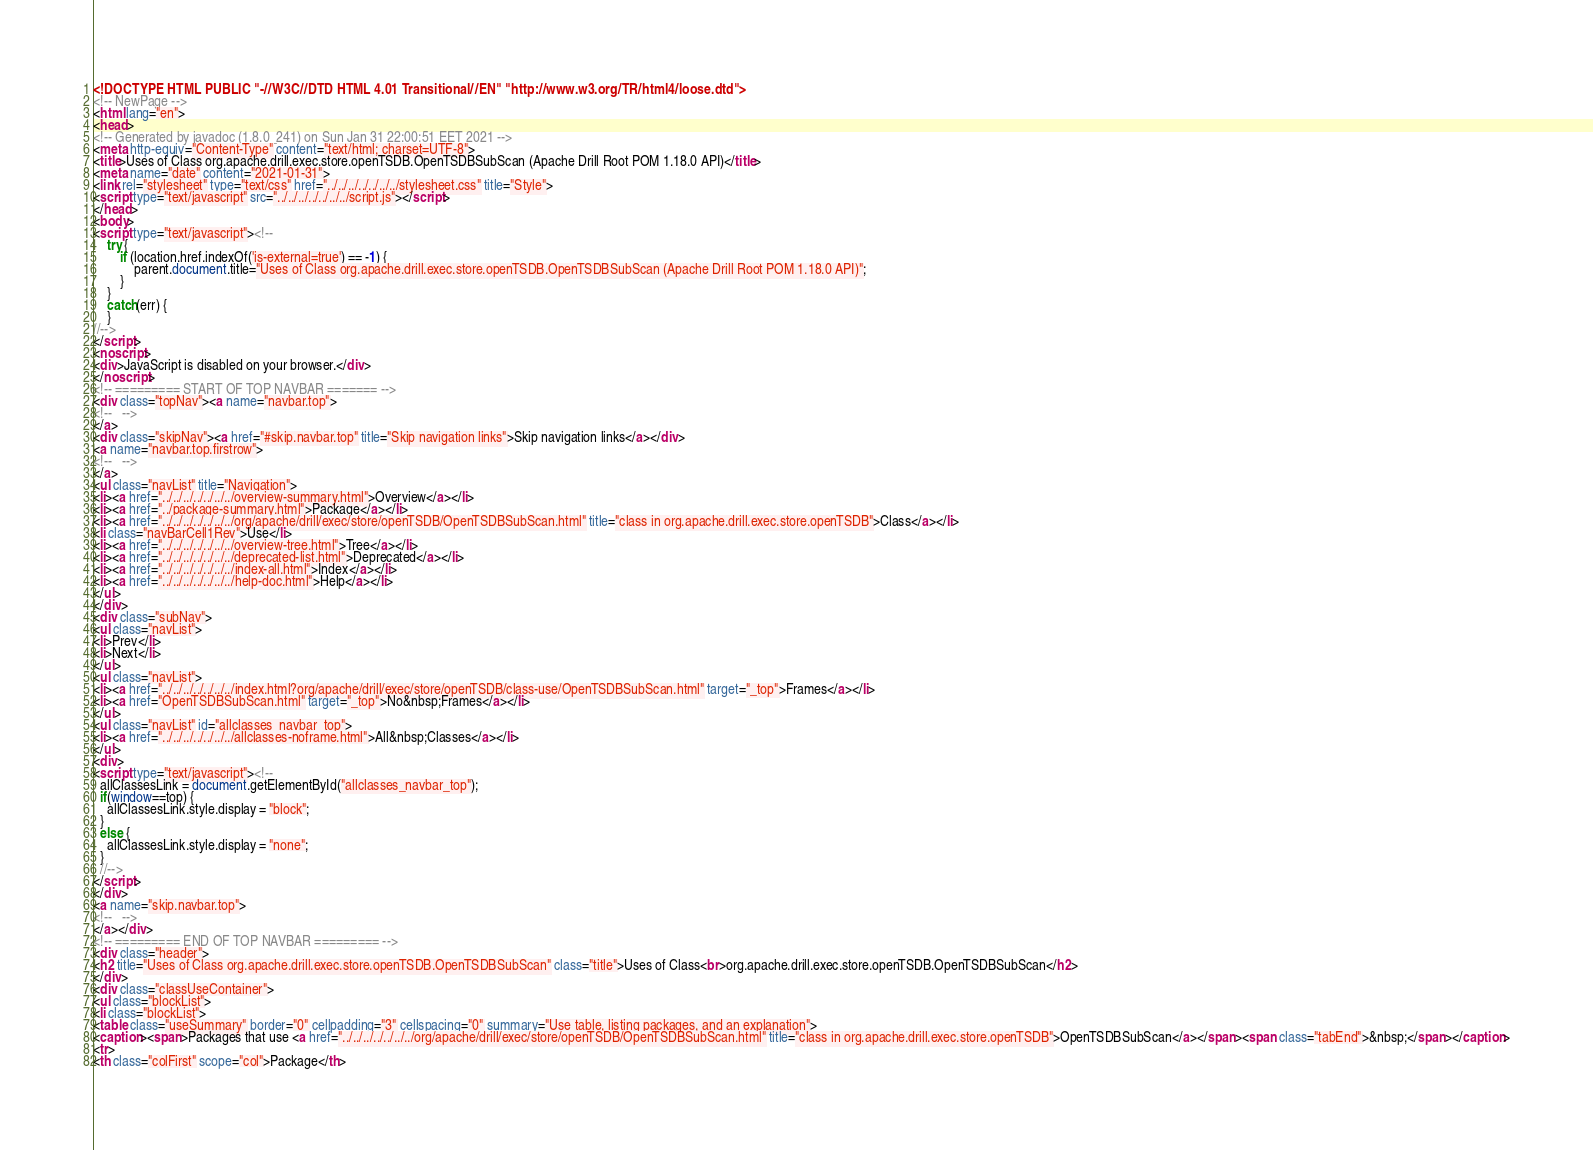Convert code to text. <code><loc_0><loc_0><loc_500><loc_500><_HTML_><!DOCTYPE HTML PUBLIC "-//W3C//DTD HTML 4.01 Transitional//EN" "http://www.w3.org/TR/html4/loose.dtd">
<!-- NewPage -->
<html lang="en">
<head>
<!-- Generated by javadoc (1.8.0_241) on Sun Jan 31 22:00:51 EET 2021 -->
<meta http-equiv="Content-Type" content="text/html; charset=UTF-8">
<title>Uses of Class org.apache.drill.exec.store.openTSDB.OpenTSDBSubScan (Apache Drill Root POM 1.18.0 API)</title>
<meta name="date" content="2021-01-31">
<link rel="stylesheet" type="text/css" href="../../../../../../../stylesheet.css" title="Style">
<script type="text/javascript" src="../../../../../../../script.js"></script>
</head>
<body>
<script type="text/javascript"><!--
    try {
        if (location.href.indexOf('is-external=true') == -1) {
            parent.document.title="Uses of Class org.apache.drill.exec.store.openTSDB.OpenTSDBSubScan (Apache Drill Root POM 1.18.0 API)";
        }
    }
    catch(err) {
    }
//-->
</script>
<noscript>
<div>JavaScript is disabled on your browser.</div>
</noscript>
<!-- ========= START OF TOP NAVBAR ======= -->
<div class="topNav"><a name="navbar.top">
<!--   -->
</a>
<div class="skipNav"><a href="#skip.navbar.top" title="Skip navigation links">Skip navigation links</a></div>
<a name="navbar.top.firstrow">
<!--   -->
</a>
<ul class="navList" title="Navigation">
<li><a href="../../../../../../../overview-summary.html">Overview</a></li>
<li><a href="../package-summary.html">Package</a></li>
<li><a href="../../../../../../../org/apache/drill/exec/store/openTSDB/OpenTSDBSubScan.html" title="class in org.apache.drill.exec.store.openTSDB">Class</a></li>
<li class="navBarCell1Rev">Use</li>
<li><a href="../../../../../../../overview-tree.html">Tree</a></li>
<li><a href="../../../../../../../deprecated-list.html">Deprecated</a></li>
<li><a href="../../../../../../../index-all.html">Index</a></li>
<li><a href="../../../../../../../help-doc.html">Help</a></li>
</ul>
</div>
<div class="subNav">
<ul class="navList">
<li>Prev</li>
<li>Next</li>
</ul>
<ul class="navList">
<li><a href="../../../../../../../index.html?org/apache/drill/exec/store/openTSDB/class-use/OpenTSDBSubScan.html" target="_top">Frames</a></li>
<li><a href="OpenTSDBSubScan.html" target="_top">No&nbsp;Frames</a></li>
</ul>
<ul class="navList" id="allclasses_navbar_top">
<li><a href="../../../../../../../allclasses-noframe.html">All&nbsp;Classes</a></li>
</ul>
<div>
<script type="text/javascript"><!--
  allClassesLink = document.getElementById("allclasses_navbar_top");
  if(window==top) {
    allClassesLink.style.display = "block";
  }
  else {
    allClassesLink.style.display = "none";
  }
  //-->
</script>
</div>
<a name="skip.navbar.top">
<!--   -->
</a></div>
<!-- ========= END OF TOP NAVBAR ========= -->
<div class="header">
<h2 title="Uses of Class org.apache.drill.exec.store.openTSDB.OpenTSDBSubScan" class="title">Uses of Class<br>org.apache.drill.exec.store.openTSDB.OpenTSDBSubScan</h2>
</div>
<div class="classUseContainer">
<ul class="blockList">
<li class="blockList">
<table class="useSummary" border="0" cellpadding="3" cellspacing="0" summary="Use table, listing packages, and an explanation">
<caption><span>Packages that use <a href="../../../../../../../org/apache/drill/exec/store/openTSDB/OpenTSDBSubScan.html" title="class in org.apache.drill.exec.store.openTSDB">OpenTSDBSubScan</a></span><span class="tabEnd">&nbsp;</span></caption>
<tr>
<th class="colFirst" scope="col">Package</th></code> 